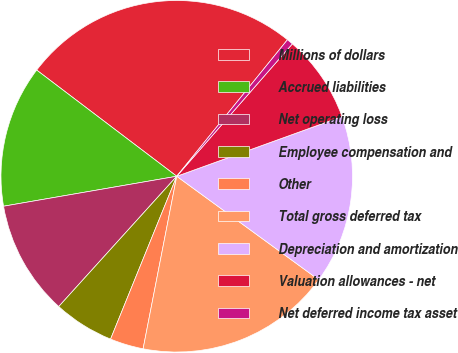Convert chart to OTSL. <chart><loc_0><loc_0><loc_500><loc_500><pie_chart><fcel>Millions of dollars<fcel>Accrued liabilities<fcel>Net operating loss<fcel>Employee compensation and<fcel>Other<fcel>Total gross deferred tax<fcel>Depreciation and amortization<fcel>Valuation allowances - net<fcel>Net deferred income tax asset<nl><fcel>25.52%<fcel>13.05%<fcel>10.56%<fcel>5.57%<fcel>3.08%<fcel>18.04%<fcel>15.54%<fcel>8.06%<fcel>0.58%<nl></chart> 